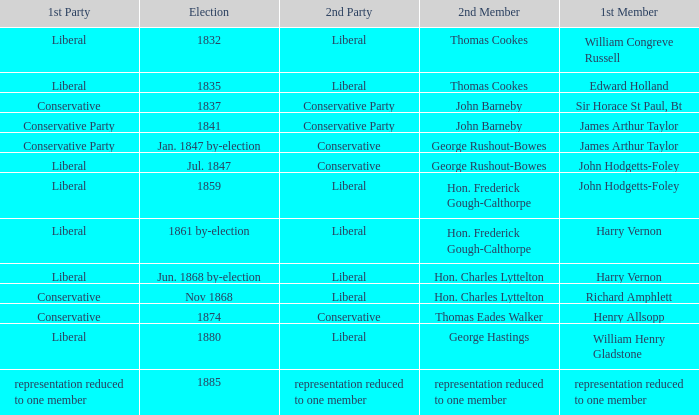What was the 2nd Party that had the 2nd Member John Barneby, when the 1st Party was Conservative? Conservative Party. 